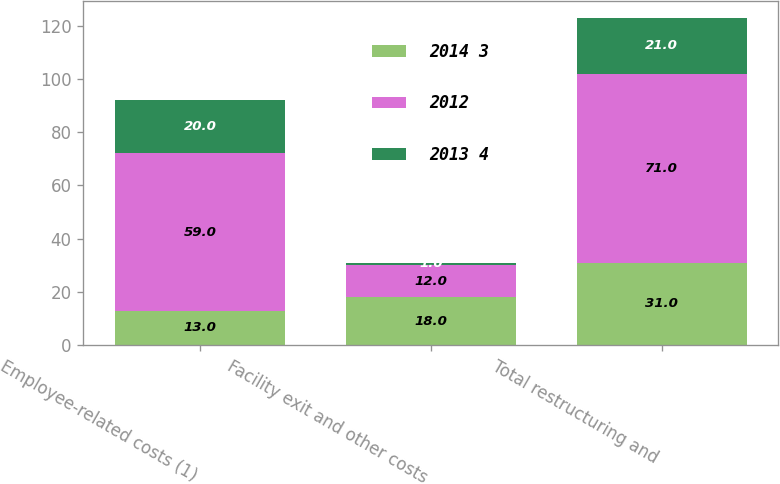Convert chart to OTSL. <chart><loc_0><loc_0><loc_500><loc_500><stacked_bar_chart><ecel><fcel>Employee-related costs (1)<fcel>Facility exit and other costs<fcel>Total restructuring and<nl><fcel>2014 3<fcel>13<fcel>18<fcel>31<nl><fcel>2012<fcel>59<fcel>12<fcel>71<nl><fcel>2013 4<fcel>20<fcel>1<fcel>21<nl></chart> 